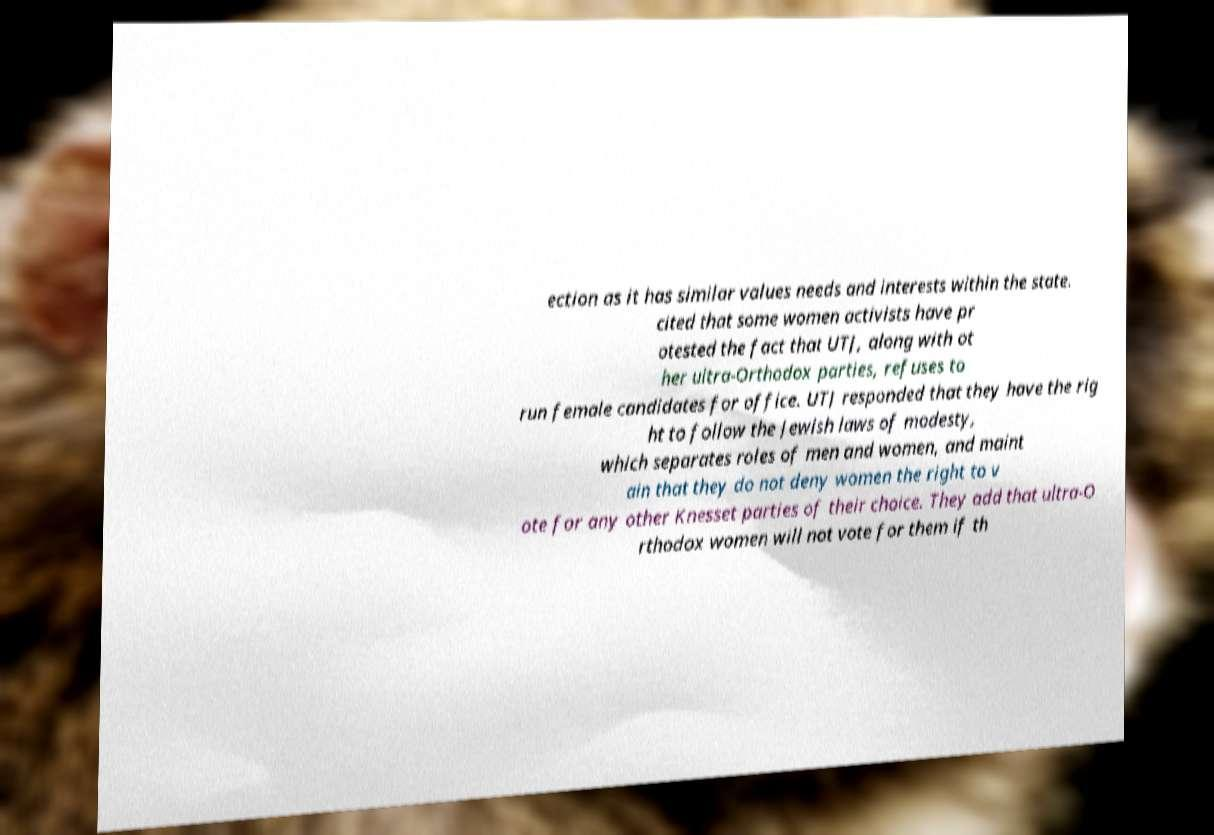Could you extract and type out the text from this image? ection as it has similar values needs and interests within the state. cited that some women activists have pr otested the fact that UTJ, along with ot her ultra-Orthodox parties, refuses to run female candidates for office. UTJ responded that they have the rig ht to follow the Jewish laws of modesty, which separates roles of men and women, and maint ain that they do not deny women the right to v ote for any other Knesset parties of their choice. They add that ultra-O rthodox women will not vote for them if th 